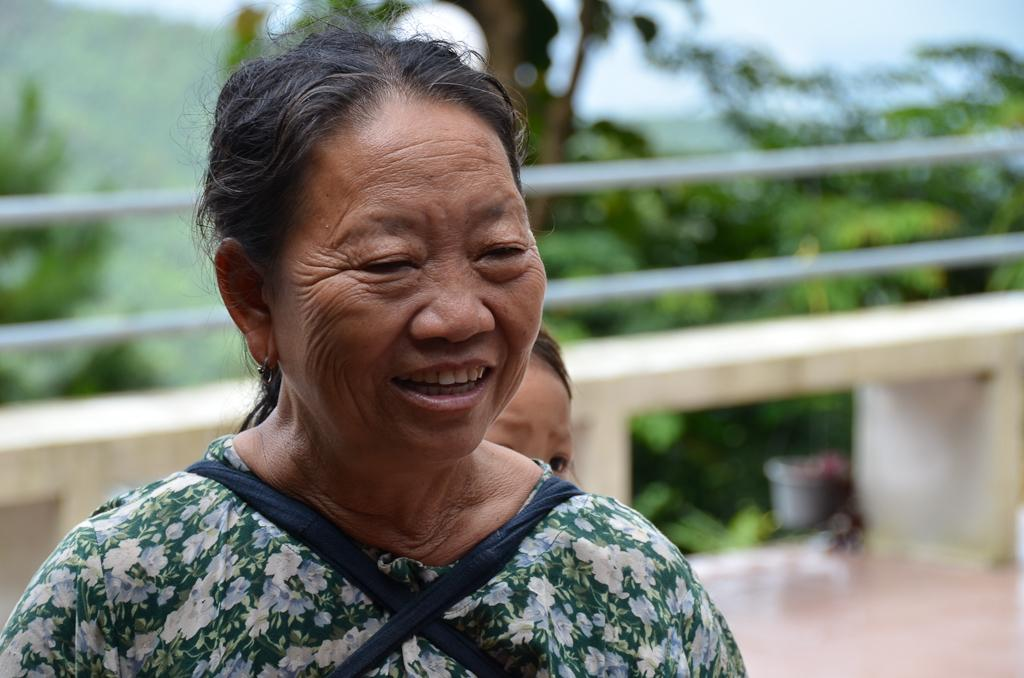How many people are in the image? There are two people in the image. Can you describe the clothing of one of the people? One person is wearing a dress with cream, blue, and green colors. What can be seen in the background of the image? There is railing and many trees visible in the background. What part of the natural environment is visible in the image? The sky is visible in the background. What tools does the carpenter use to measure the distance between the trees in the image? There is no carpenter present in the image, nor are any tools or measurements being taken. 